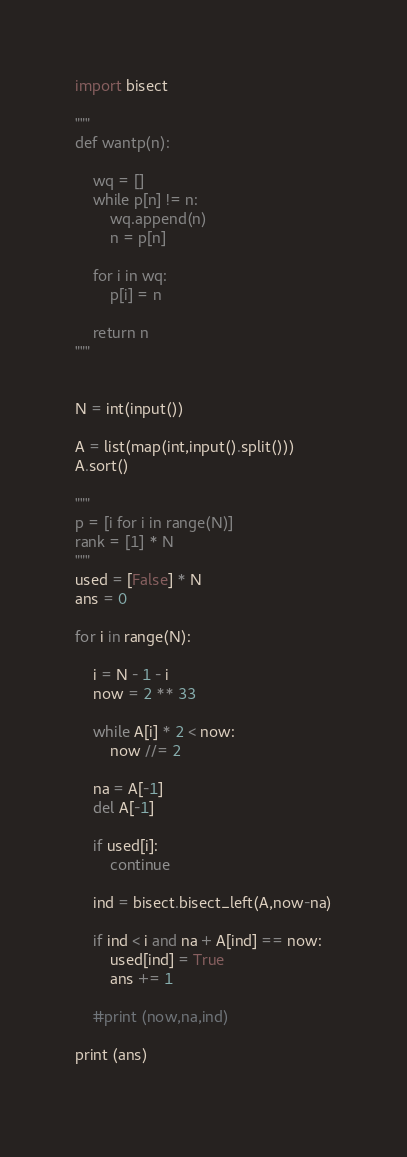<code> <loc_0><loc_0><loc_500><loc_500><_Python_>
import bisect

"""
def wantp(n):

    wq = []
    while p[n] != n:
        wq.append(n)
        n = p[n]

    for i in wq:
        p[i] = n

    return n
"""


N = int(input())

A = list(map(int,input().split()))
A.sort()

"""
p = [i for i in range(N)]
rank = [1] * N
"""
used = [False] * N
ans = 0

for i in range(N):

    i = N - 1 - i
    now = 2 ** 33

    while A[i] * 2 < now:
        now //= 2

    na = A[-1]
    del A[-1]

    if used[i]:
        continue

    ind = bisect.bisect_left(A,now-na)

    if ind < i and na + A[ind] == now:
        used[ind] = True
        ans += 1

    #print (now,na,ind)

print (ans)
        
</code> 